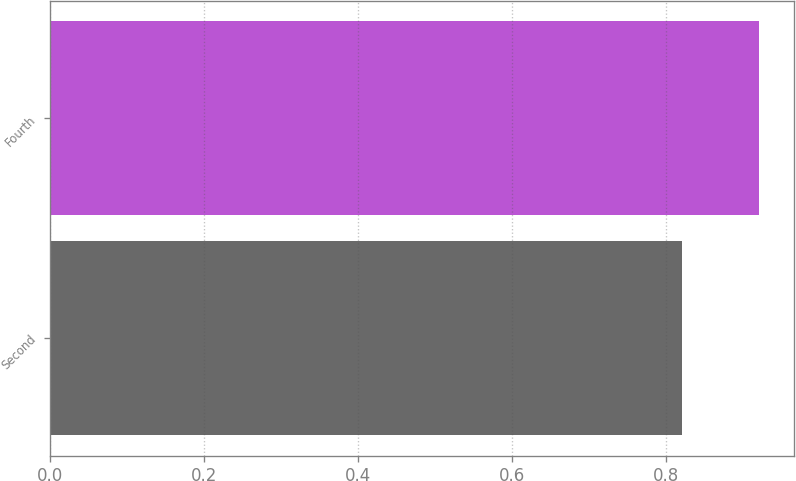Convert chart. <chart><loc_0><loc_0><loc_500><loc_500><bar_chart><fcel>Second<fcel>Fourth<nl><fcel>0.82<fcel>0.92<nl></chart> 